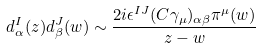<formula> <loc_0><loc_0><loc_500><loc_500>d _ { \alpha } ^ { I } ( z ) d _ { \beta } ^ { J } ( w ) \sim \frac { 2 i \epsilon ^ { I J } ( C \gamma _ { \mu } ) _ { \alpha \beta } \pi ^ { \mu } ( w ) } { z - w }</formula> 